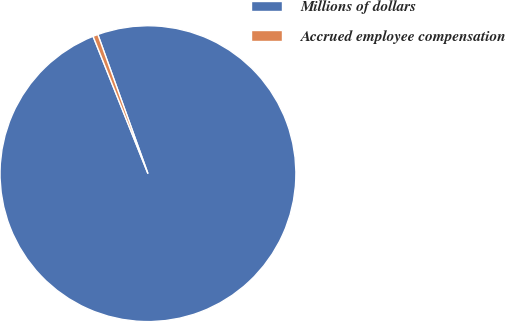Convert chart. <chart><loc_0><loc_0><loc_500><loc_500><pie_chart><fcel>Millions of dollars<fcel>Accrued employee compensation<nl><fcel>99.45%<fcel>0.55%<nl></chart> 